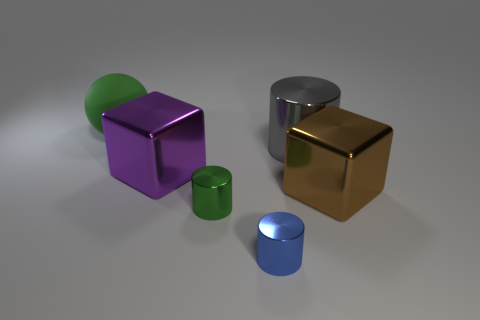Is there anything else that has the same material as the sphere?
Give a very brief answer. No. Is the large cylinder made of the same material as the large purple thing?
Ensure brevity in your answer.  Yes. How many things are small objects that are to the right of the small green thing or objects to the right of the large green rubber thing?
Your answer should be compact. 5. Is there a blue object that has the same size as the matte ball?
Keep it short and to the point. No. There is another object that is the same shape as the large purple shiny object; what color is it?
Offer a very short reply. Brown. Are there any large things in front of the cube on the left side of the big brown thing?
Provide a succinct answer. Yes. There is a small shiny object that is left of the blue thing; is its shape the same as the gray metallic object?
Your answer should be very brief. Yes. The big green rubber object is what shape?
Provide a short and direct response. Sphere. How many cylinders have the same material as the tiny blue thing?
Your answer should be compact. 2. Is the color of the rubber thing the same as the cube that is left of the brown shiny object?
Your response must be concise. No. 